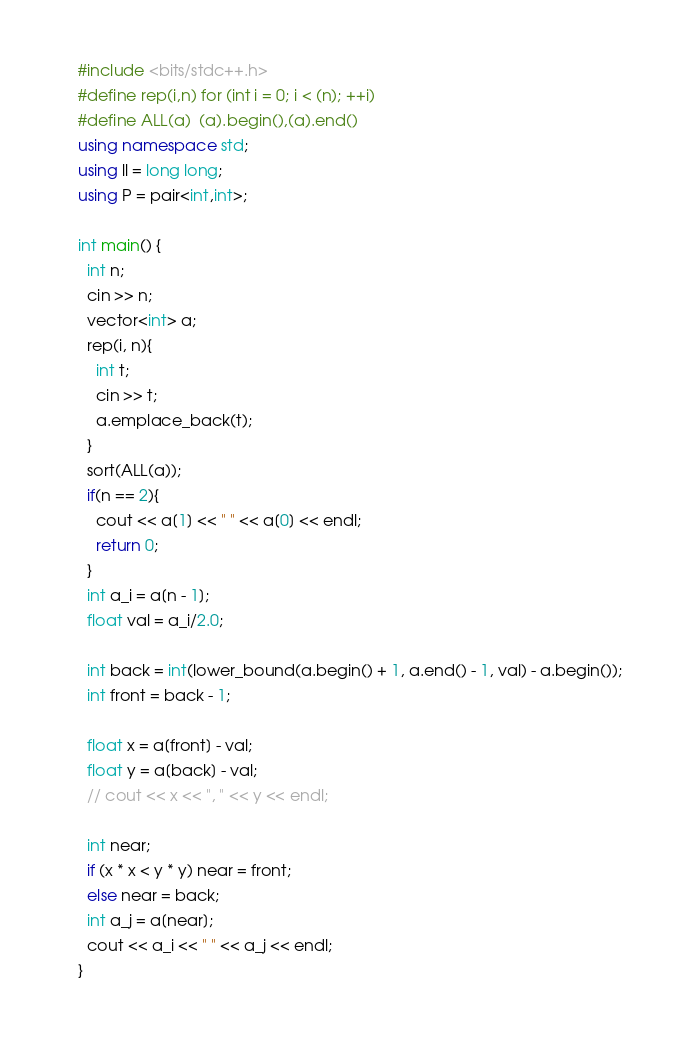<code> <loc_0><loc_0><loc_500><loc_500><_C++_>#include <bits/stdc++.h>
#define rep(i,n) for (int i = 0; i < (n); ++i)
#define ALL(a)  (a).begin(),(a).end()
using namespace std;
using ll = long long;
using P = pair<int,int>;

int main() {
  int n;
  cin >> n;
  vector<int> a;
  rep(i, n){
    int t;
    cin >> t;
    a.emplace_back(t);
  }
  sort(ALL(a));
  if(n == 2){
    cout << a[1] << " " << a[0] << endl;
    return 0;
  }
  int a_i = a[n - 1];
  float val = a_i/2.0;

  int back = int(lower_bound(a.begin() + 1, a.end() - 1, val) - a.begin());
  int front = back - 1;

  float x = a[front] - val;
  float y = a[back] - val;
  // cout << x << ", " << y << endl;

  int near;
  if (x * x < y * y) near = front;
  else near = back;
  int a_j = a[near];
  cout << a_i << " " << a_j << endl;
}
</code> 